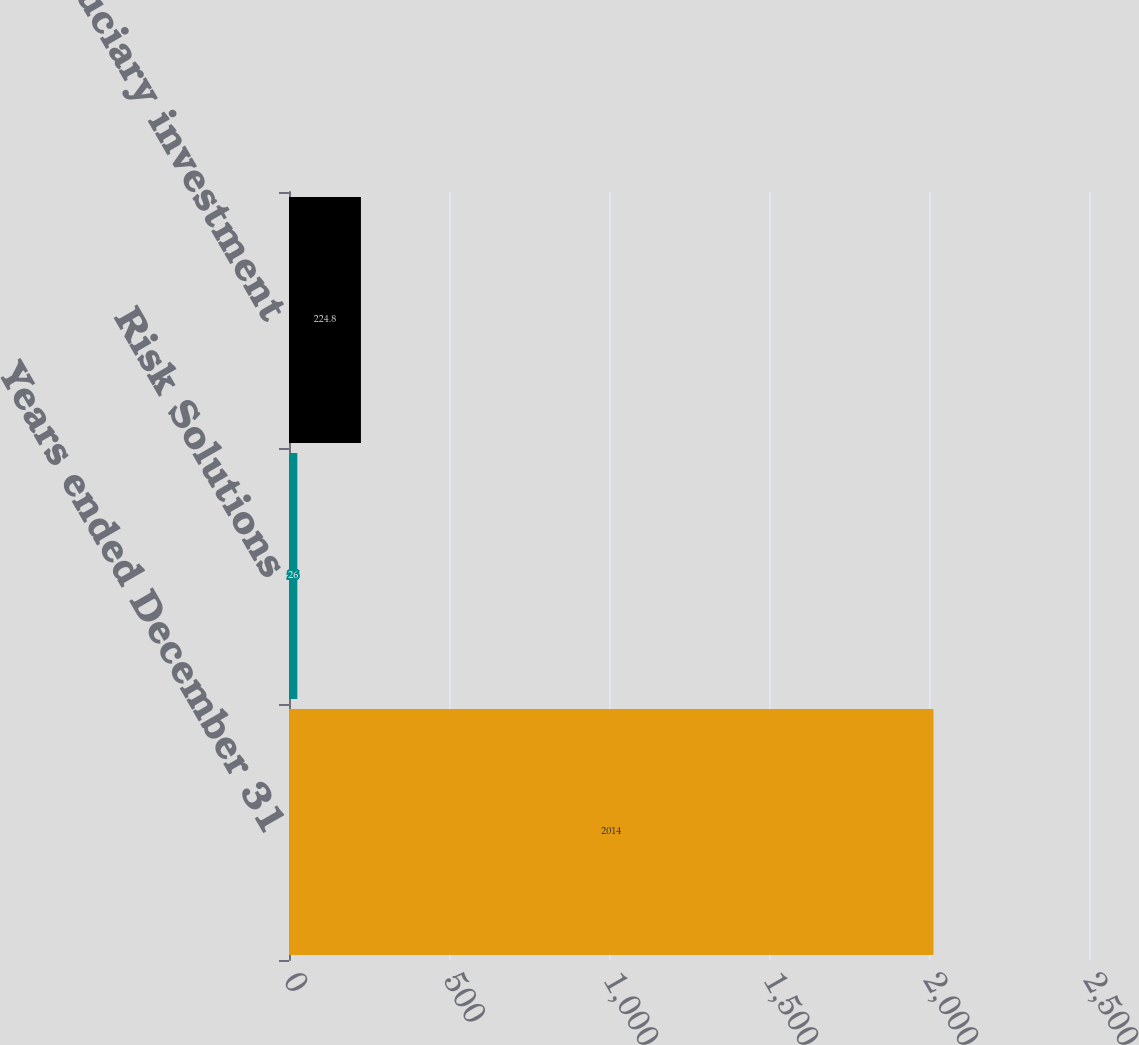Convert chart. <chart><loc_0><loc_0><loc_500><loc_500><bar_chart><fcel>Years ended December 31<fcel>Risk Solutions<fcel>Total fiduciary investment<nl><fcel>2014<fcel>26<fcel>224.8<nl></chart> 